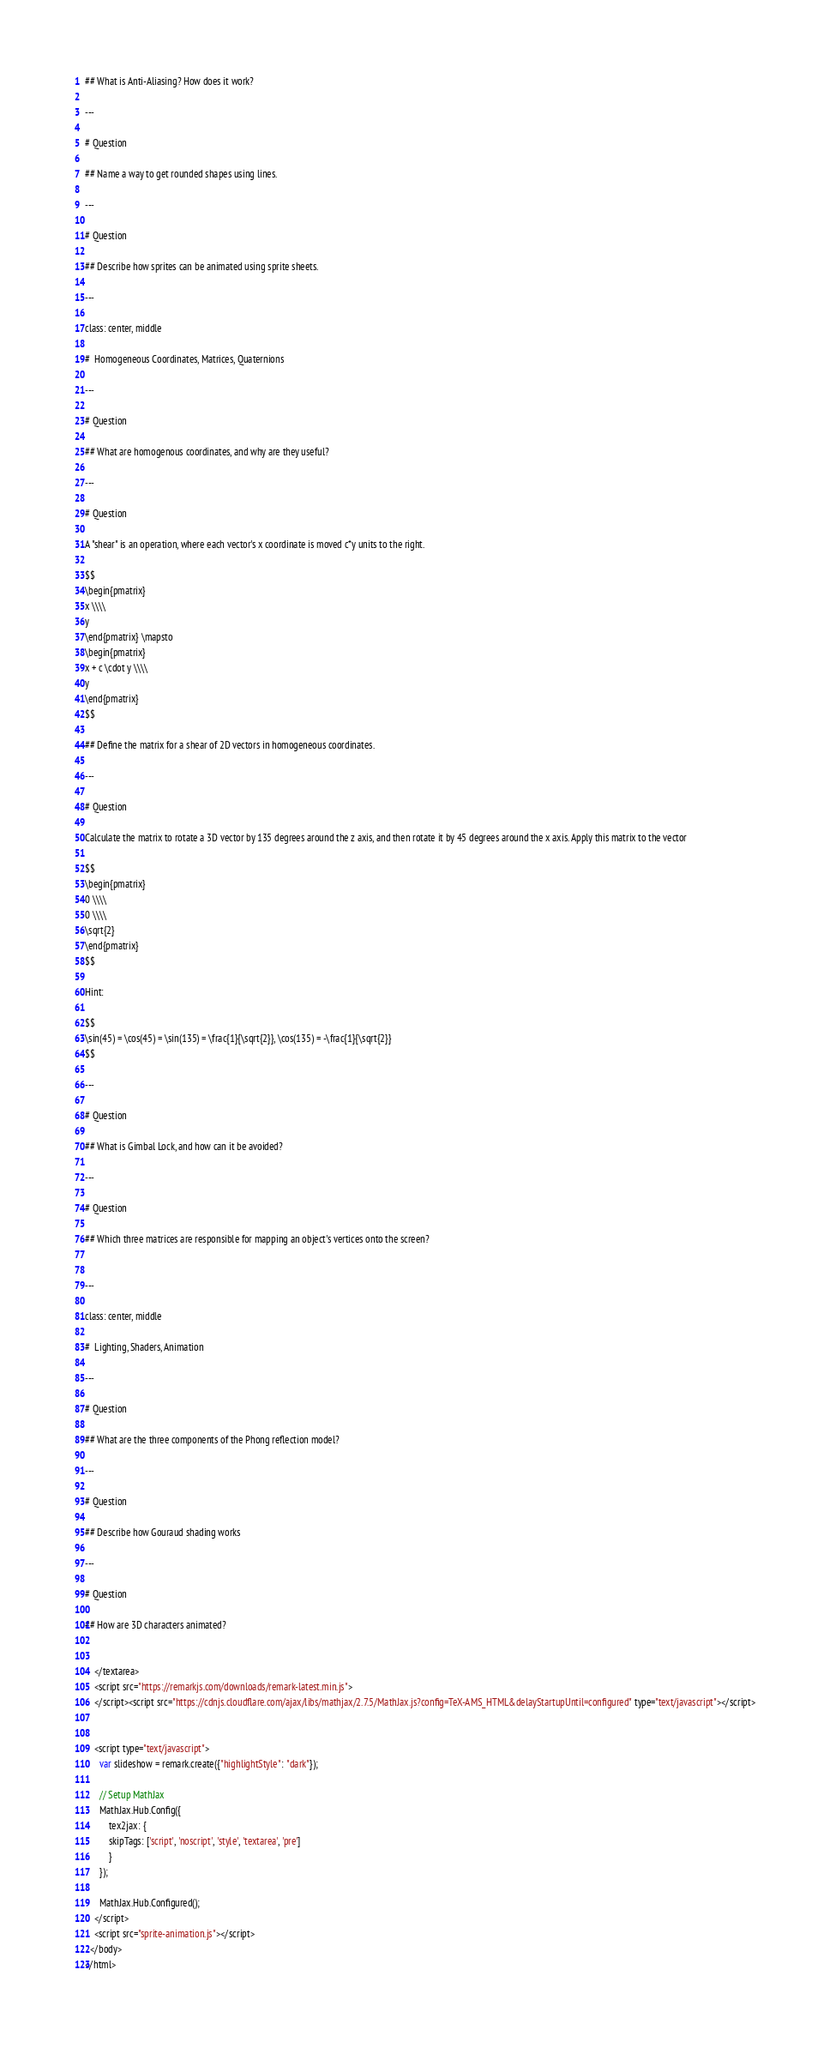<code> <loc_0><loc_0><loc_500><loc_500><_HTML_>## What is Anti-Aliasing? How does it work?

---

# Question 

## Name a way to get rounded shapes using lines.

---

# Question 

## Describe how sprites can be animated using sprite sheets.

---

class: center, middle

#  Homogeneous Coordinates, Matrices, Quaternions

---

# Question 

## What are homogenous coordinates, and why are they useful?

---

# Question 

A "shear" is an operation, where each vector's x coordinate is moved c*y units to the right.

$$
\begin{pmatrix} 
x \\\\ 
y
\end{pmatrix} \mapsto 
\begin{pmatrix} 
x + c \cdot y \\\\ 
y
\end{pmatrix}
$$

## Define the matrix for a shear of 2D vectors in homogeneous coordinates.

---

# Question 

Calculate the matrix to rotate a 3D vector by 135 degrees around the z axis, and then rotate it by 45 degrees around the x axis. Apply this matrix to the vector

$$
\begin{pmatrix} 
0 \\\\ 
0 \\\\
\sqrt{2}
\end{pmatrix}
$$

Hint:

$$
\sin(45) = \cos(45) = \sin(135) = \frac{1}{\sqrt{2}}, \cos(135) = -\frac{1}{\sqrt{2}}
$$

---

# Question 

## What is Gimbal Lock, and how can it be avoided?

---

# Question 

## Which three matrices are responsible for mapping an object's vertices onto the screen?


---

class: center, middle

#  Lighting, Shaders, Animation

---

# Question 

## What are the three components of the Phong reflection model?

---

# Question 

## Describe how Gouraud shading works 

---

# Question 

## How are 3D characters animated?


    </textarea>
    <script src="https://remarkjs.com/downloads/remark-latest.min.js">
    </script><script src="https://cdnjs.cloudflare.com/ajax/libs/mathjax/2.7.5/MathJax.js?config=TeX-AMS_HTML&delayStartupUntil=configured" type="text/javascript"></script>
    
    
    <script type="text/javascript">
      var slideshow = remark.create({"highlightStyle": "dark"});

      // Setup MathJax
      MathJax.Hub.Config({
          tex2jax: {
          skipTags: ['script', 'noscript', 'style', 'textarea', 'pre']
          }
      });

      MathJax.Hub.Configured();
    </script>
    <script src="sprite-animation.js"></script>
  </body>
</html></code> 